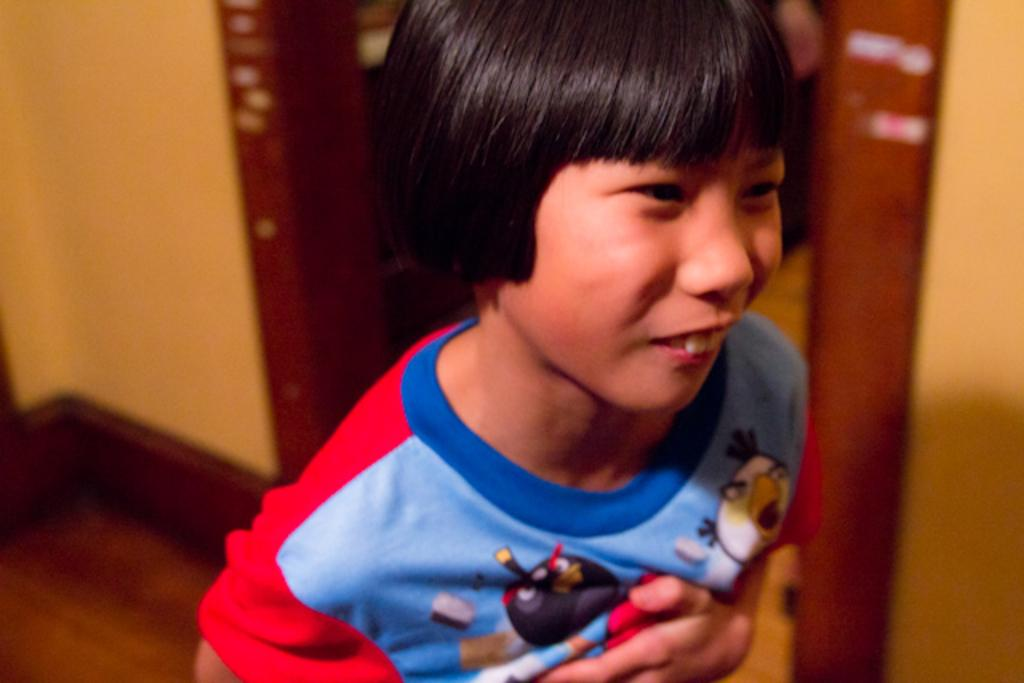What is the main subject in the center of the image? There is a boy in the center of the image. What is the boy wearing? The boy is wearing a red and blue t-shirt. What can be seen in the background of the image? There is a door for entrance and a plain wall in the background of the image. What part of the room is visible in the image? The floor is visible in the image. What direction is the boy facing in relation to the north in the image? The image does not provide information about the direction the boy is facing or the concept of north, so it cannot be determined. 